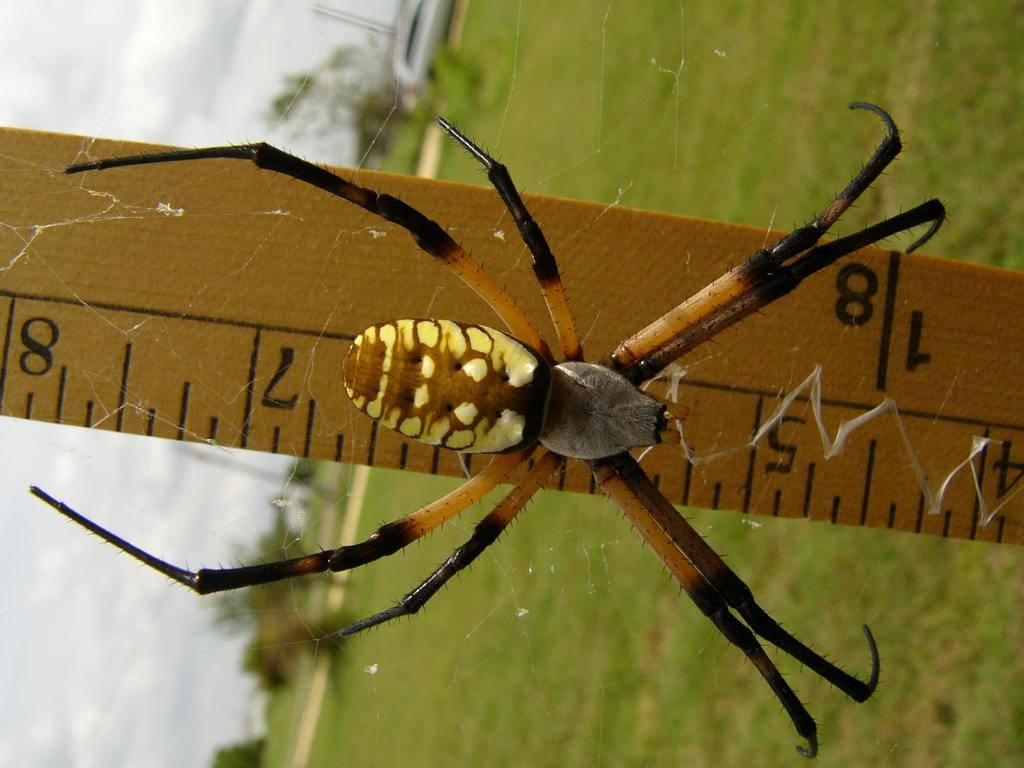What is the main object in the image? There is a measuring scale in the image. What is located on the glass in the image? There is a spider on the glass in the image. What type of vegetation can be seen on the ground in the image? Grass is visible on the ground in the image. What other natural elements are present in the image? There are trees in the image. How would you describe the weather in the image? The sky is cloudy in the image. How does the stranger use the measuring scale in the image? There is no stranger present in the image, so it is not possible to determine how they might use the measuring scale. 